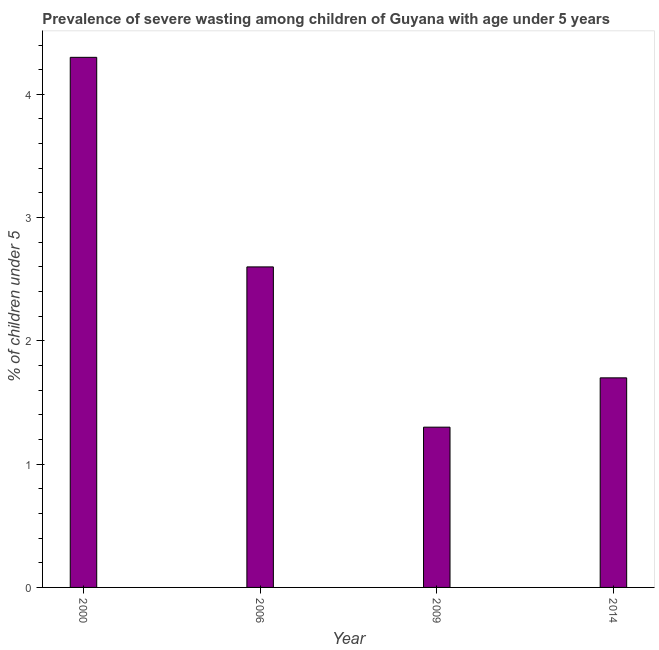What is the title of the graph?
Your response must be concise. Prevalence of severe wasting among children of Guyana with age under 5 years. What is the label or title of the X-axis?
Offer a very short reply. Year. What is the label or title of the Y-axis?
Make the answer very short.  % of children under 5. What is the prevalence of severe wasting in 2000?
Offer a very short reply. 4.3. Across all years, what is the maximum prevalence of severe wasting?
Give a very brief answer. 4.3. Across all years, what is the minimum prevalence of severe wasting?
Your answer should be compact. 1.3. In which year was the prevalence of severe wasting maximum?
Provide a succinct answer. 2000. In which year was the prevalence of severe wasting minimum?
Your response must be concise. 2009. What is the sum of the prevalence of severe wasting?
Keep it short and to the point. 9.9. What is the difference between the prevalence of severe wasting in 2009 and 2014?
Offer a very short reply. -0.4. What is the average prevalence of severe wasting per year?
Make the answer very short. 2.48. What is the median prevalence of severe wasting?
Your response must be concise. 2.15. In how many years, is the prevalence of severe wasting greater than 3.4 %?
Your answer should be very brief. 1. What is the ratio of the prevalence of severe wasting in 2000 to that in 2014?
Offer a terse response. 2.53. Is the sum of the prevalence of severe wasting in 2000 and 2006 greater than the maximum prevalence of severe wasting across all years?
Provide a short and direct response. Yes. In how many years, is the prevalence of severe wasting greater than the average prevalence of severe wasting taken over all years?
Give a very brief answer. 2. How many years are there in the graph?
Give a very brief answer. 4. What is the  % of children under 5 of 2000?
Give a very brief answer. 4.3. What is the  % of children under 5 of 2006?
Your answer should be compact. 2.6. What is the  % of children under 5 of 2009?
Keep it short and to the point. 1.3. What is the  % of children under 5 of 2014?
Make the answer very short. 1.7. What is the difference between the  % of children under 5 in 2000 and 2006?
Give a very brief answer. 1.7. What is the difference between the  % of children under 5 in 2000 and 2014?
Provide a short and direct response. 2.6. What is the difference between the  % of children under 5 in 2006 and 2009?
Give a very brief answer. 1.3. What is the difference between the  % of children under 5 in 2006 and 2014?
Offer a terse response. 0.9. What is the ratio of the  % of children under 5 in 2000 to that in 2006?
Your answer should be compact. 1.65. What is the ratio of the  % of children under 5 in 2000 to that in 2009?
Your answer should be very brief. 3.31. What is the ratio of the  % of children under 5 in 2000 to that in 2014?
Your answer should be compact. 2.53. What is the ratio of the  % of children under 5 in 2006 to that in 2014?
Your answer should be very brief. 1.53. What is the ratio of the  % of children under 5 in 2009 to that in 2014?
Provide a short and direct response. 0.77. 